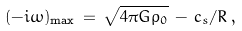<formula> <loc_0><loc_0><loc_500><loc_500>( - i \omega ) _ { \max } \, = \, \sqrt { 4 \pi G \rho _ { 0 } } \, - \, c _ { s } / R \, ,</formula> 